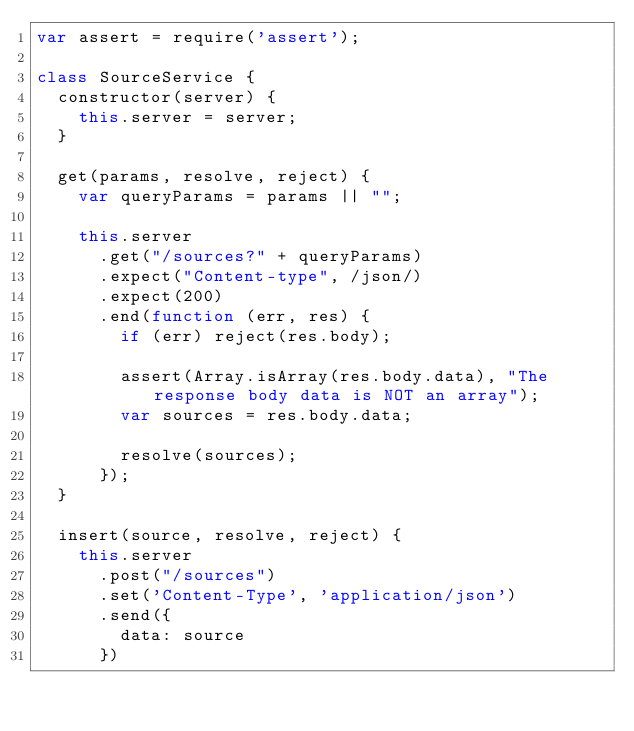Convert code to text. <code><loc_0><loc_0><loc_500><loc_500><_JavaScript_>var assert = require('assert');

class SourceService {
  constructor(server) {
    this.server = server;
  }

  get(params, resolve, reject) {
    var queryParams = params || "";

    this.server
      .get("/sources?" + queryParams)
      .expect("Content-type", /json/)
      .expect(200)
      .end(function (err, res) {
        if (err) reject(res.body);

        assert(Array.isArray(res.body.data), "The response body data is NOT an array");
        var sources = res.body.data;

        resolve(sources);
      });
  }

  insert(source, resolve, reject) {
    this.server
      .post("/sources")
      .set('Content-Type', 'application/json')
      .send({
        data: source
      })</code> 